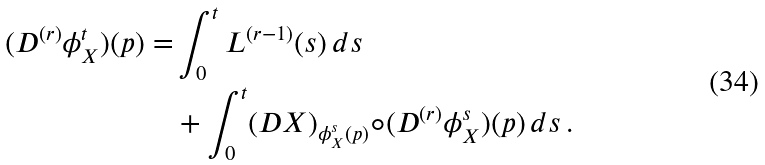<formula> <loc_0><loc_0><loc_500><loc_500>( D ^ { ( r ) } \phi ^ { t } _ { X } ) ( p ) = & \int _ { 0 } ^ { t } L ^ { ( r - 1 ) } ( s ) \, d s \, \\ & + \int _ { 0 } ^ { t } ( D X ) _ { \phi ^ { s } _ { X } ( p ) } \circ ( D ^ { ( r ) } \phi ^ { s } _ { X } ) ( p ) \, d s \, .</formula> 